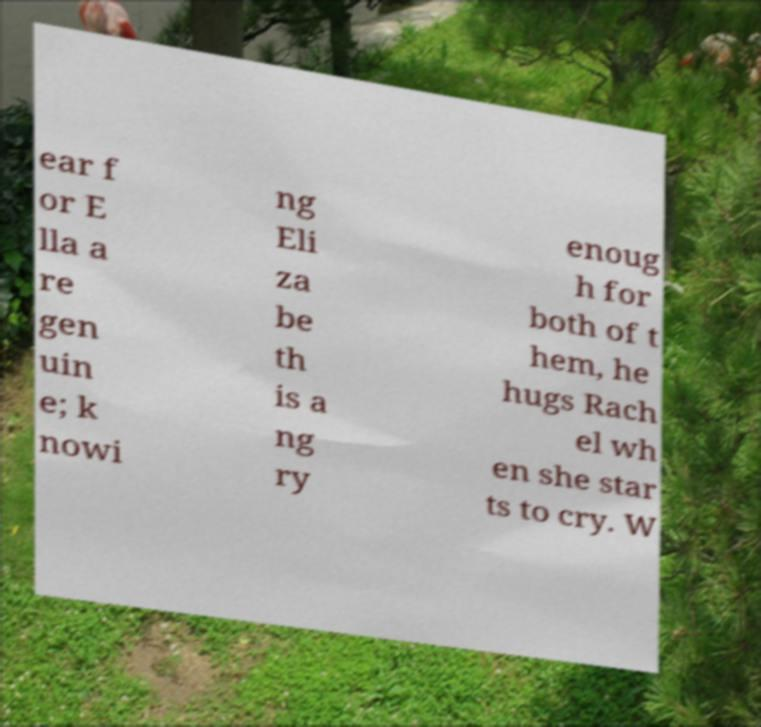Could you extract and type out the text from this image? ear f or E lla a re gen uin e; k nowi ng Eli za be th is a ng ry enoug h for both of t hem, he hugs Rach el wh en she star ts to cry. W 